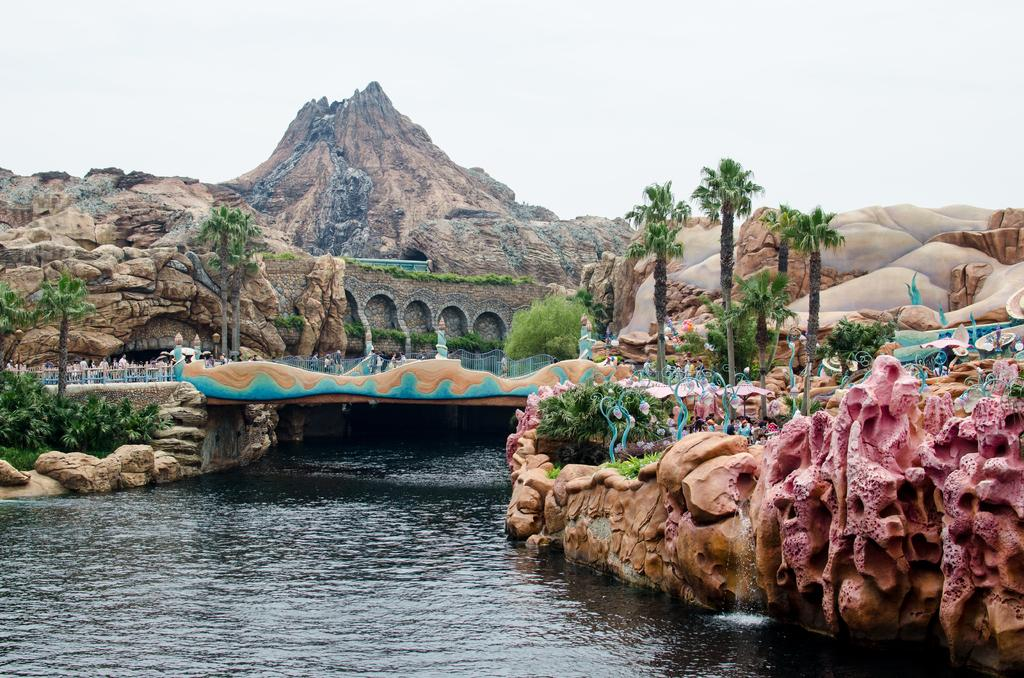What type of natural elements can be seen in the image? There are trees in the image. What man-made structure is present in the image? There is a bridge in the image. What part of the natural environment is visible in the image? The sky is visible in the image. What type of geological feature is present in the image? There is a rock in the image. What additional feature can be observed about the rocks in the image? There are colorful rocks in the image. What type of icicle can be seen hanging from the bridge in the image? There is no icicle present in the image; it is not cold enough for icicles to form. What color is the scarf wrapped around the tree in the image? There is no scarf present in the image; only trees, a bridge, rocks, and the sky are visible. 